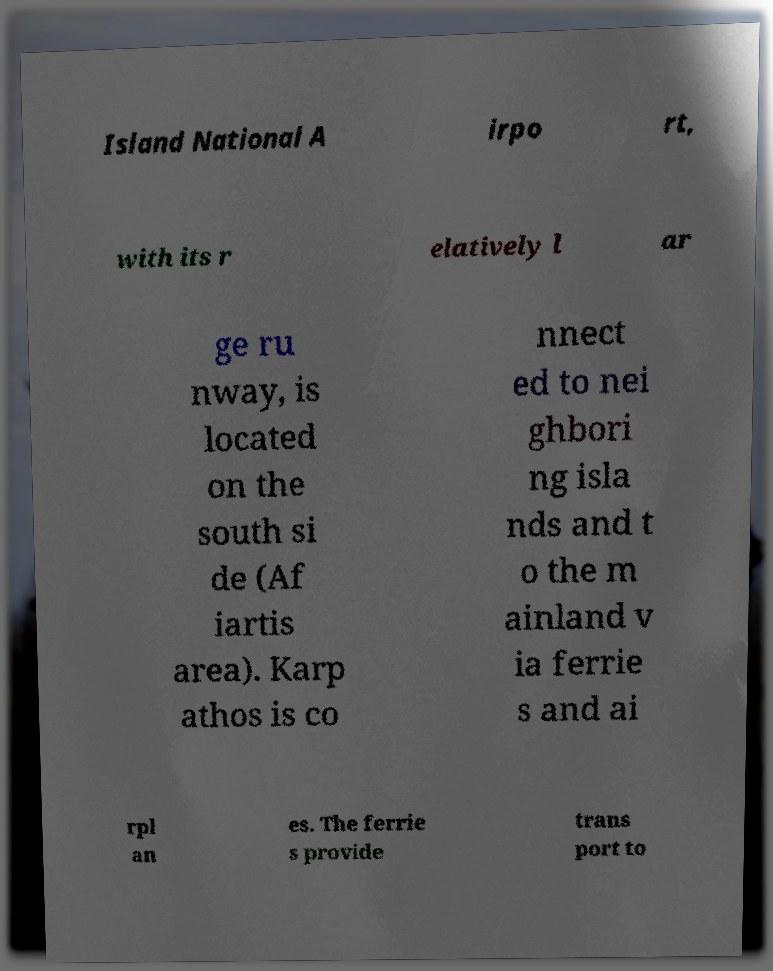Could you extract and type out the text from this image? Island National A irpo rt, with its r elatively l ar ge ru nway, is located on the south si de (Af iartis area). Karp athos is co nnect ed to nei ghbori ng isla nds and t o the m ainland v ia ferrie s and ai rpl an es. The ferrie s provide trans port to 